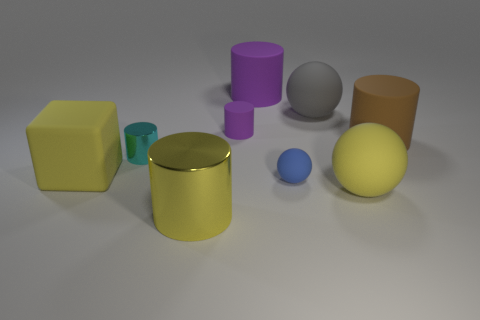Subtract all large brown rubber cylinders. How many cylinders are left? 4 Subtract 1 cylinders. How many cylinders are left? 4 Subtract all yellow cylinders. How many cylinders are left? 4 Subtract all red cylinders. Subtract all green spheres. How many cylinders are left? 5 Add 1 yellow rubber objects. How many objects exist? 10 Subtract all cylinders. How many objects are left? 4 Add 1 purple things. How many purple things exist? 3 Subtract 0 cyan spheres. How many objects are left? 9 Subtract all small blue cubes. Subtract all purple matte cylinders. How many objects are left? 7 Add 1 brown things. How many brown things are left? 2 